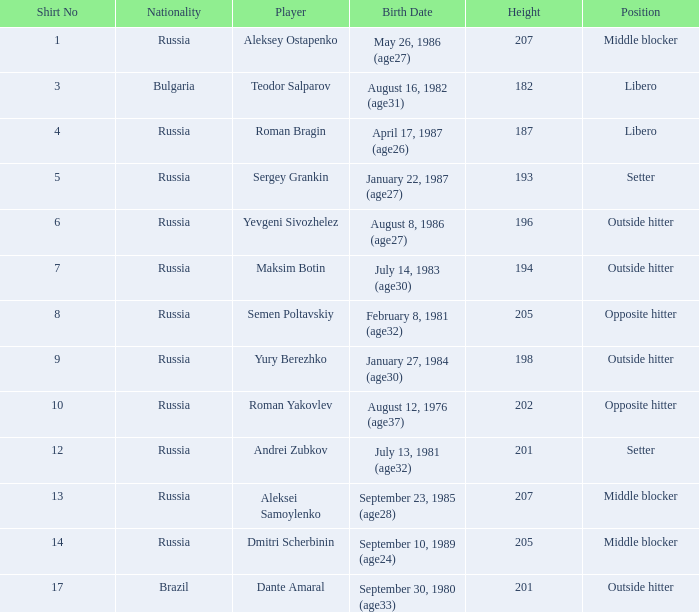What is Maksim Botin's position?  Outside hitter. 